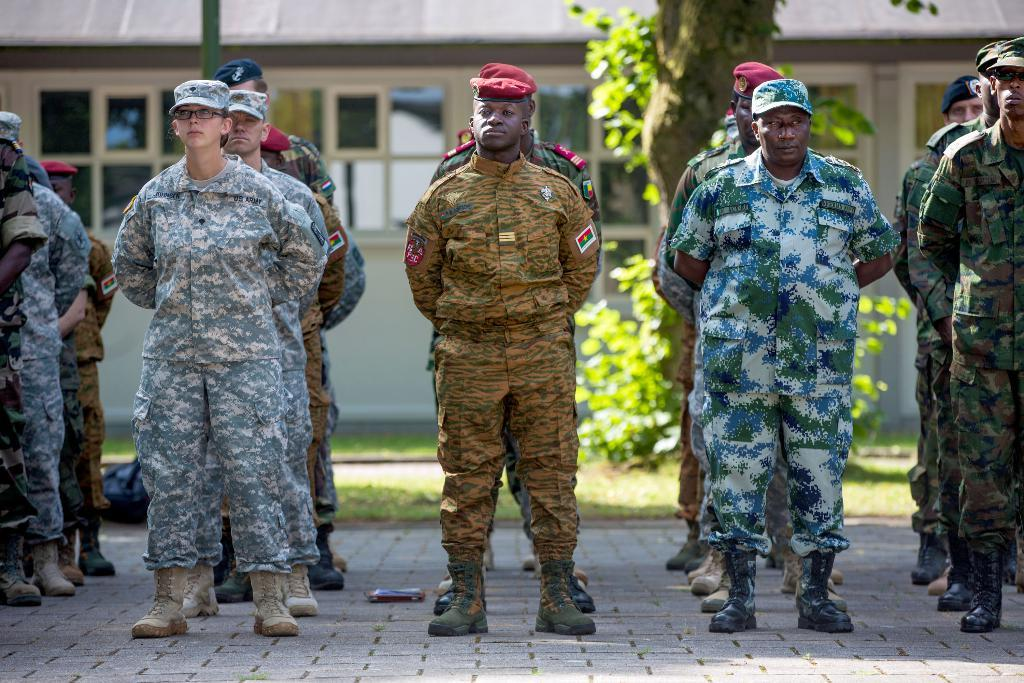What are the people in the image wearing? The people in the image are wearing army dresses. What can be seen in the background of the image? There is a house, plants, a tree stem, and grass in the background of the image. Can you describe the vegetation present in the background? The vegetation includes plants and grass. How does the grandmother react to the earthquake in the image? There is no grandmother or earthquake present in the image. What type of tramp is visible in the image? There is no tramp present in the image. 